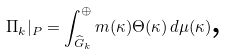<formula> <loc_0><loc_0><loc_500><loc_500>\Pi _ { k } | _ { P } = \int _ { \widehat { G } _ { k } } ^ { \oplus } m ( \kappa ) \Theta ( \kappa ) \, d \mu ( \kappa ) \text {,}</formula> 